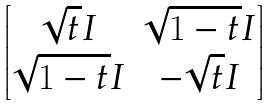Convert formula to latex. <formula><loc_0><loc_0><loc_500><loc_500>\begin{bmatrix} \sqrt { t } I & \sqrt { 1 - t } I \\ \sqrt { 1 - t } I & - \sqrt { t } I \end{bmatrix}</formula> 